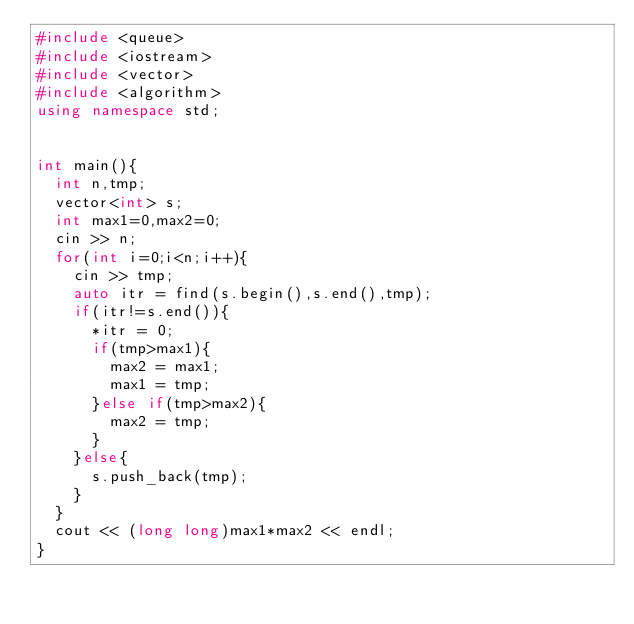Convert code to text. <code><loc_0><loc_0><loc_500><loc_500><_C++_>#include <queue>
#include <iostream>
#include <vector>
#include <algorithm>
using namespace std;


int main(){
  int n,tmp;
  vector<int> s;
  int max1=0,max2=0;
  cin >> n;
  for(int i=0;i<n;i++){
    cin >> tmp;
    auto itr = find(s.begin(),s.end(),tmp);
    if(itr!=s.end()){
      *itr = 0;
      if(tmp>max1){
        max2 = max1;
        max1 = tmp;
      }else if(tmp>max2){
        max2 = tmp;
      }
    }else{
      s.push_back(tmp);
    }
  }
  cout << (long long)max1*max2 << endl;
}
</code> 